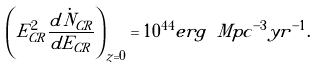<formula> <loc_0><loc_0><loc_500><loc_500>\left ( E _ { C R } ^ { 2 } { \frac { d \dot { N } _ { C R } } { d E _ { C R } } } \right ) _ { z = 0 } = 1 0 ^ { 4 4 } e r g \ M p c ^ { - 3 } y r ^ { - 1 } .</formula> 